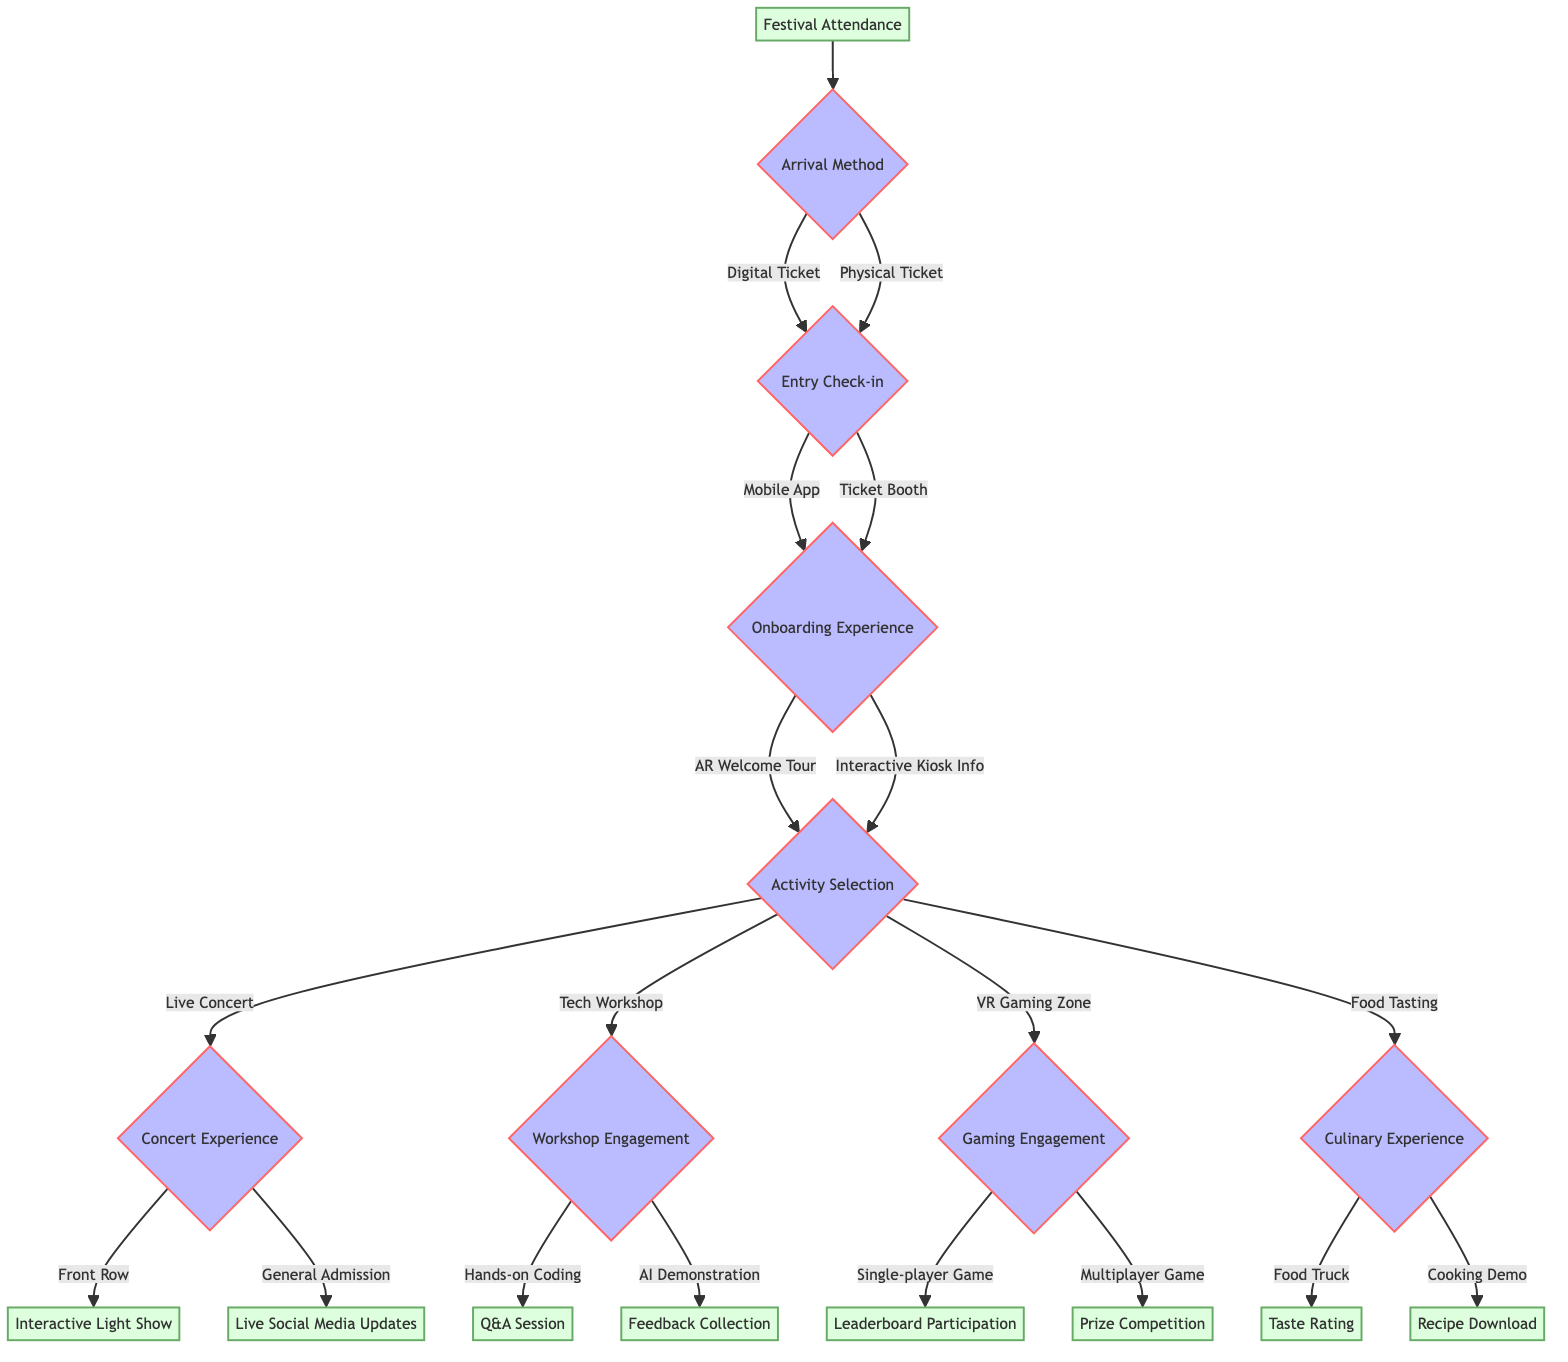What's the first decision point in the diagram? The diagram starts with "Arrival Method" as the first decision point after "Festival Attendance". This is indicated directly under the "Festival Attendance" node.
Answer: Arrival Method How many options are there under the "Activity Selection" decision? Under the "Activity Selection" decision, there are four options: Live Concert, Tech Workshop, VR Gaming Zone, and Food Tasting, totaling four options.
Answer: Four What happens after selecting "Front Row" in the Concert Experience? After selecting "Front Row", the next step leads to "Interactive Light Show." This is indicated as the next node in the flowchart.
Answer: Interactive Light Show Which option leads to "Recipe Download"? Choosing "Cooking Demo" under the "Culinary Experience" leads to "Recipe Download". This can be traced moving through the decisions from Culinary Experience to Cooking Demo.
Answer: Recipe Download If a festival-goer arrives by a digital ticket, what is their next step? If a digital ticket is chosen, the next step for the festival-goer is "Entry Check-in." This is the immediate next node connected to the "Arrival Method" for that choice.
Answer: Entry Check-in What decision follows "Onboarding Experience"? After "Onboarding Experience", the next decision is "Activity Selection." This is the only pathway from Onboarding Experience depicted in the diagram.
Answer: Activity Selection Which engagement activities can someone participate in after the "Gaming Engagement"? After "Gaming Engagement", there are two outcomes: "Leaderboard Participation" after a Single-player Game and "Prize Competition" after a Multiplayer Game. Both options represent engagement activities directly linked from Gaming Engagement.
Answer: Leaderboard Participation, Prize Competition What decision comes directly after the "Ticket Booth"? After selecting "Ticket Booth" in the "Entry Check-in", the decision that comes next is "Onboarding Experience." This is the next step following the Ticket Booth choice.
Answer: Onboarding Experience 